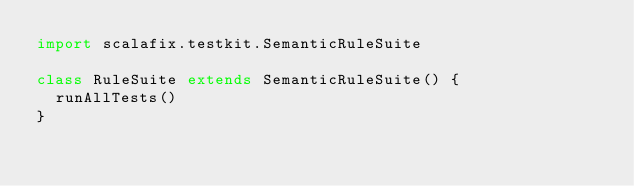<code> <loc_0><loc_0><loc_500><loc_500><_Scala_>import scalafix.testkit.SemanticRuleSuite

class RuleSuite extends SemanticRuleSuite() {
  runAllTests()
}
</code> 